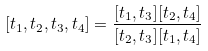<formula> <loc_0><loc_0><loc_500><loc_500>[ t _ { 1 } , t _ { 2 } , t _ { 3 } , t _ { 4 } ] = \frac { [ t _ { 1 } , t _ { 3 } ] [ t _ { 2 } , t _ { 4 } ] } { [ t _ { 2 } , t _ { 3 } ] [ t _ { 1 } , t _ { 4 } ] }</formula> 